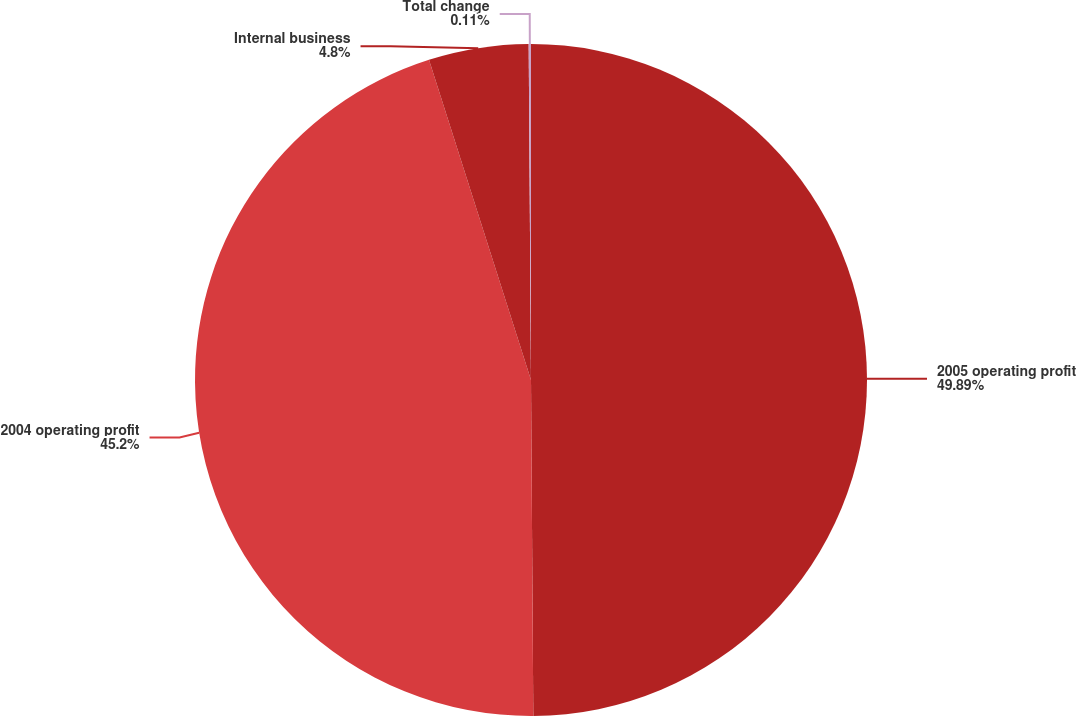Convert chart to OTSL. <chart><loc_0><loc_0><loc_500><loc_500><pie_chart><fcel>2005 operating profit<fcel>2004 operating profit<fcel>Internal business<fcel>Total change<nl><fcel>49.89%<fcel>45.2%<fcel>4.8%<fcel>0.11%<nl></chart> 